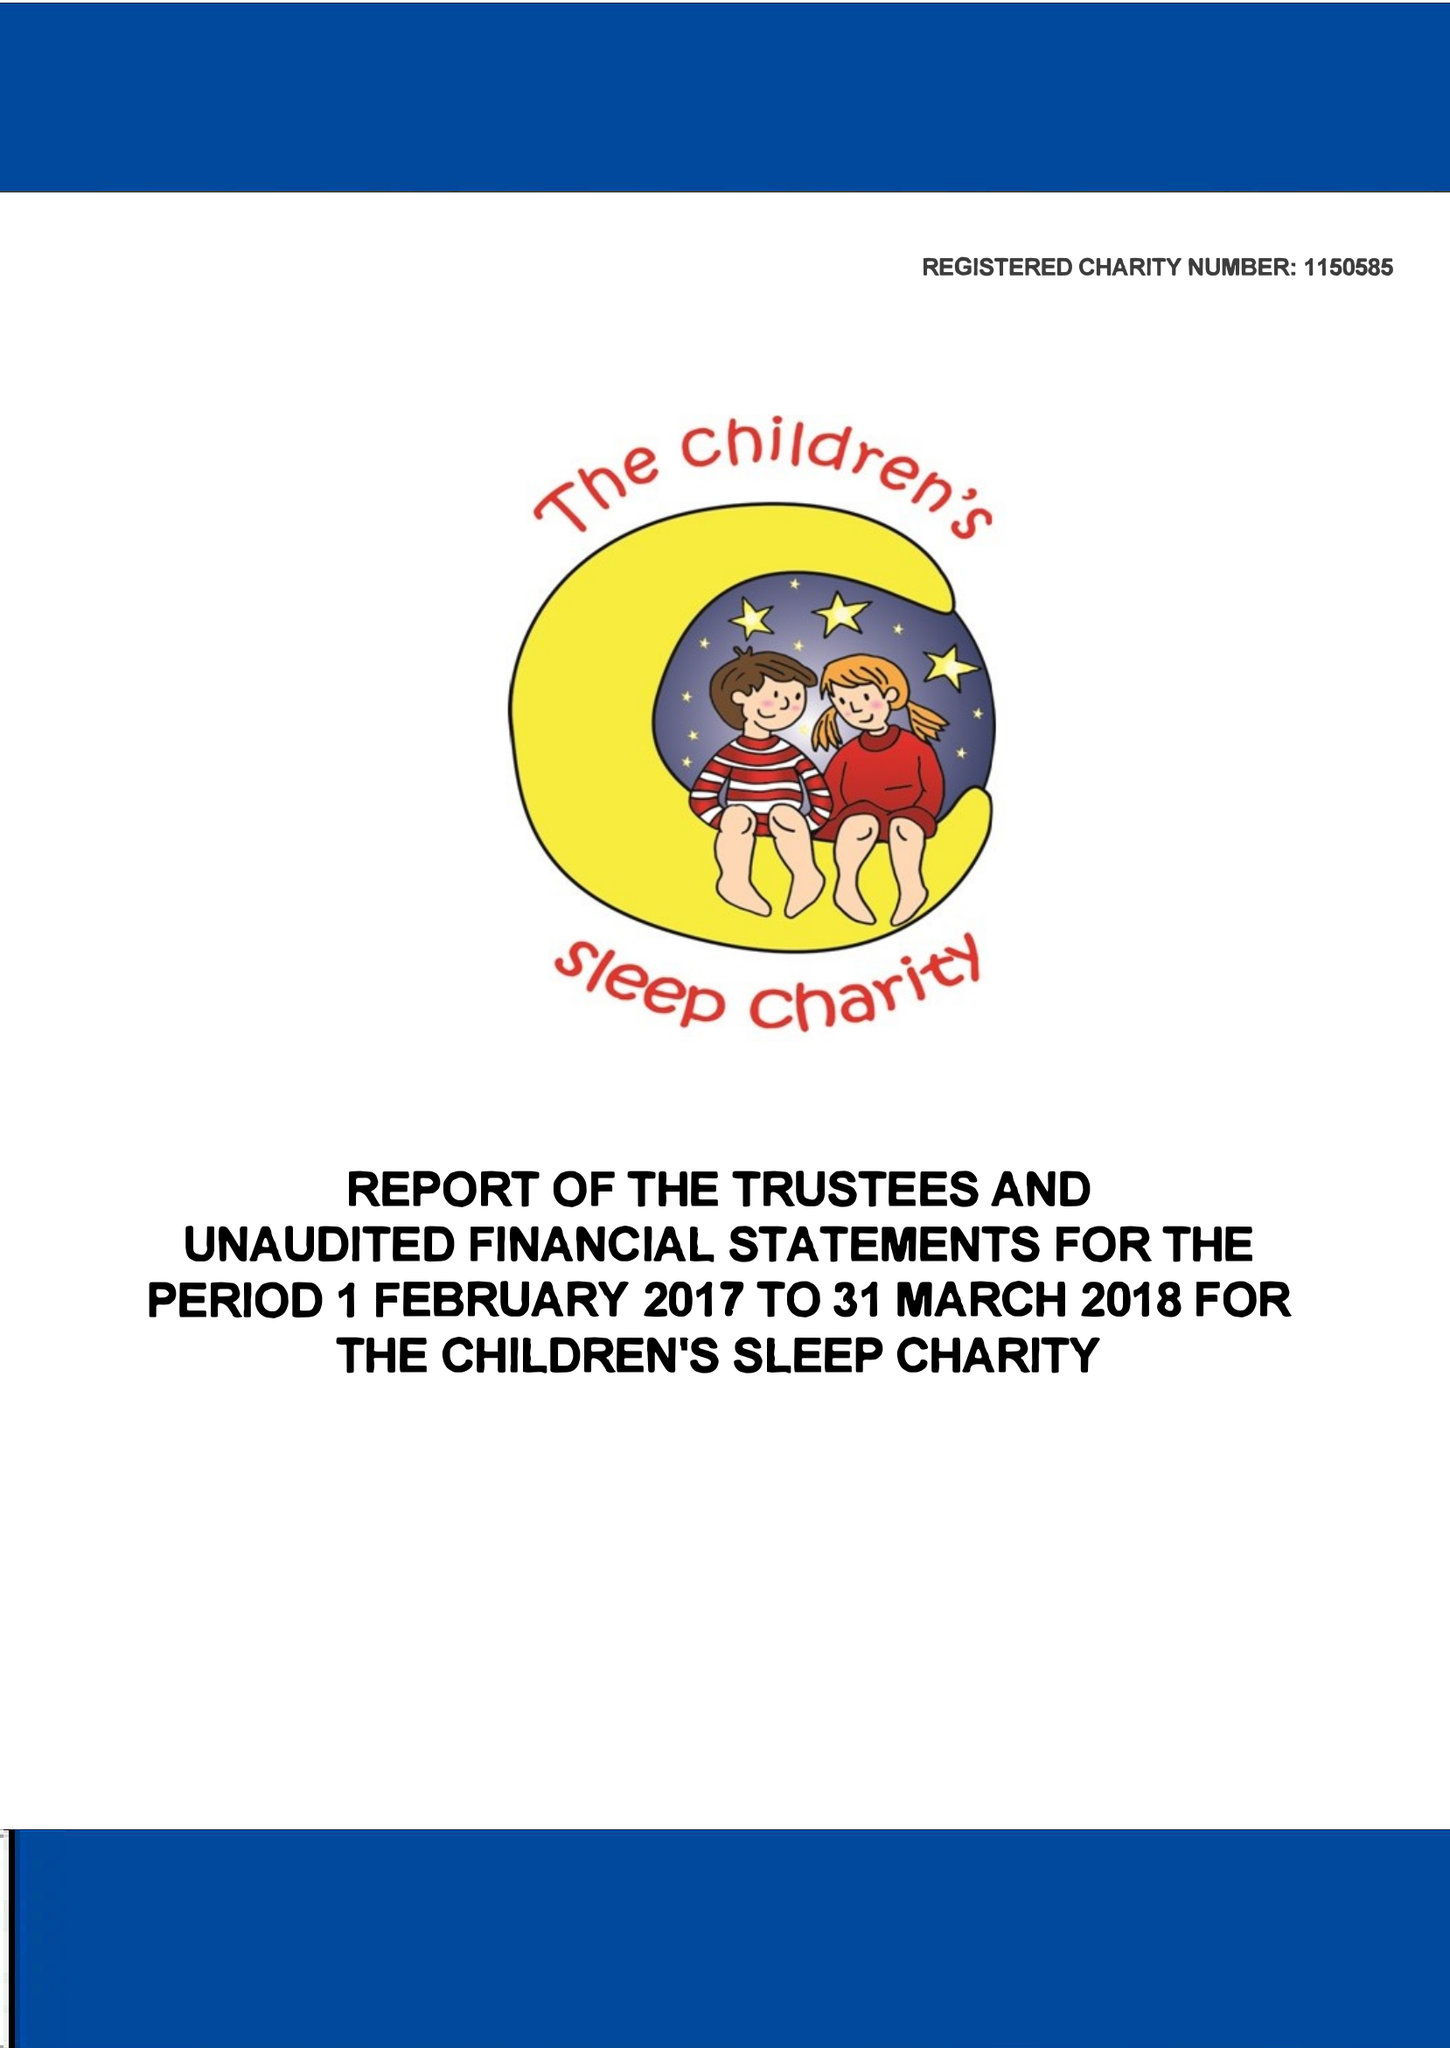What is the value for the address__postcode?
Answer the question using a single word or phrase. DN4 8QP 